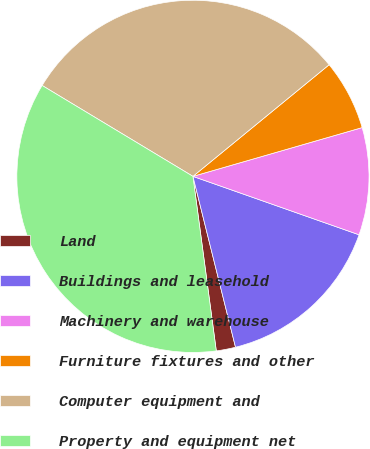<chart> <loc_0><loc_0><loc_500><loc_500><pie_chart><fcel>Land<fcel>Buildings and leasehold<fcel>Machinery and warehouse<fcel>Furniture fixtures and other<fcel>Computer equipment and<fcel>Property and equipment net<nl><fcel>1.77%<fcel>15.73%<fcel>9.85%<fcel>6.46%<fcel>30.44%<fcel>35.75%<nl></chart> 